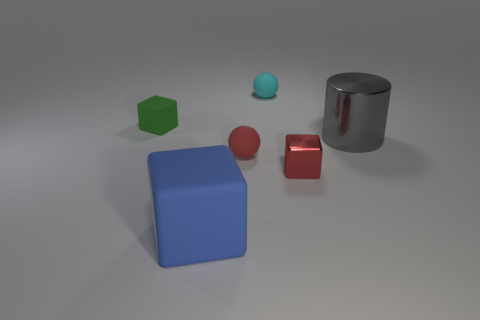Subtract all gray blocks. Subtract all cyan spheres. How many blocks are left? 3 Add 4 purple metal things. How many objects exist? 10 Subtract all spheres. How many objects are left? 4 Subtract 0 cyan cylinders. How many objects are left? 6 Subtract all blue rubber objects. Subtract all small green objects. How many objects are left? 4 Add 5 small metallic blocks. How many small metallic blocks are left? 6 Add 1 cyan rubber spheres. How many cyan rubber spheres exist? 2 